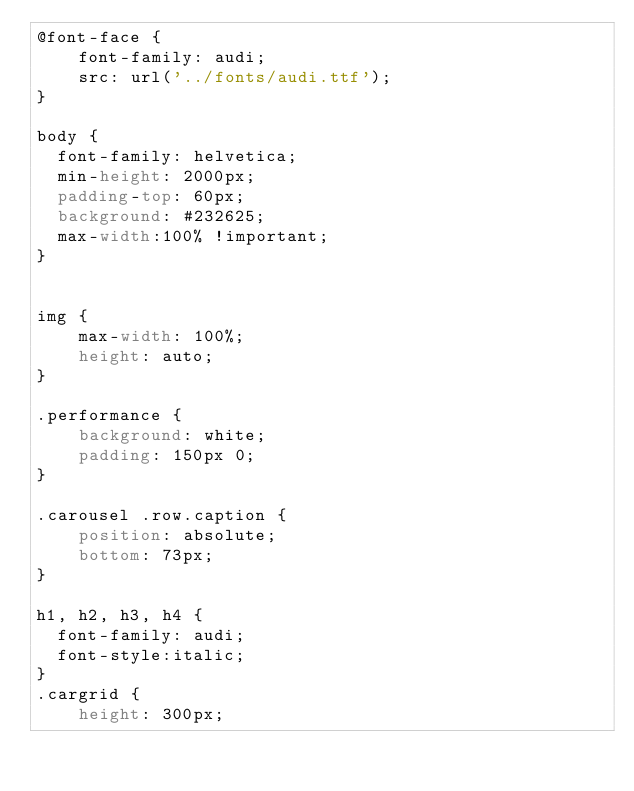<code> <loc_0><loc_0><loc_500><loc_500><_CSS_>@font-face {
    font-family: audi;
    src: url('../fonts/audi.ttf');
}

body {
  font-family: helvetica;
  min-height: 2000px;
  padding-top: 60px;
  background: #232625;
  max-width:100% !important;
}


img {
    max-width: 100%;
    height: auto;
}

.performance {
    background: white;
    padding: 150px 0;
}

.carousel .row.caption {
    position: absolute;
    bottom: 73px;
}

h1, h2, h3, h4 {
  font-family: audi;
  font-style:italic;
}
.cargrid {
    height: 300px;</code> 